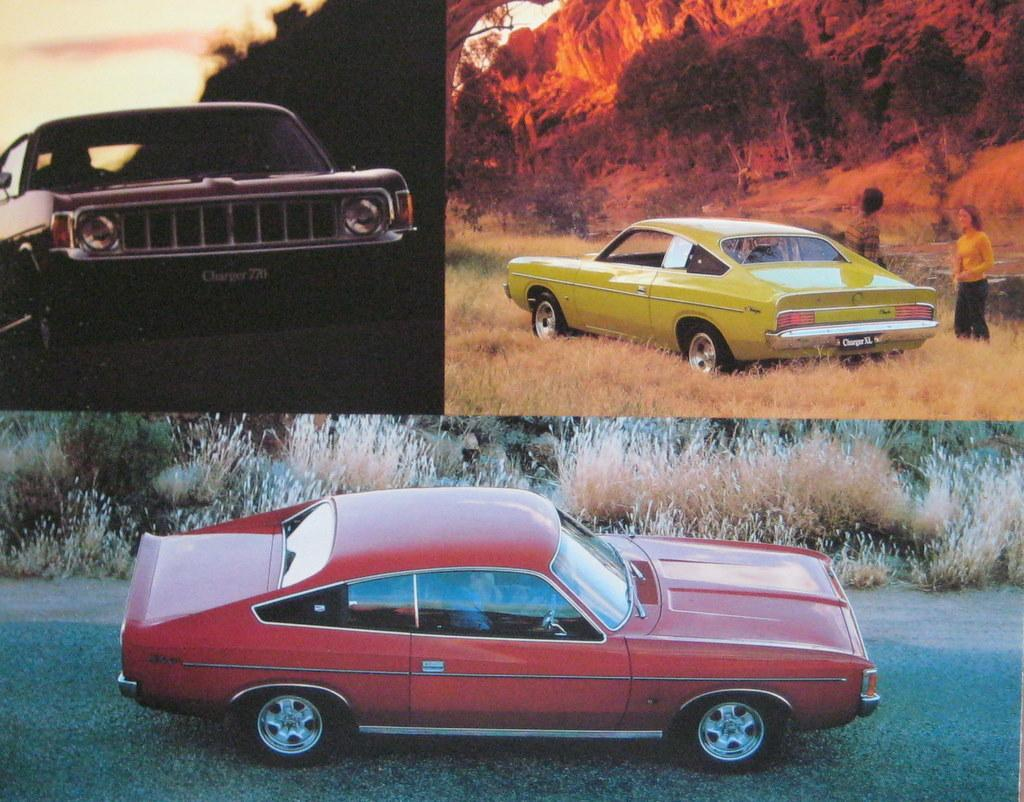How many cars are in the image? There are three cars in the image. What colors are the cars? The cars are in red, yellow, and black colors. What can be seen in the background of the image? There are trees visible in the background. Are there any people in the image? Yes, there are two people in the background. What type of vegetation is present in the image? Dry grass is present in the image. What type of blood is visible on the cars in the image? There is no blood visible on the cars in the image. Can you hear any thunder in the image? The image is silent, and there is no indication of thunder or any sound. 